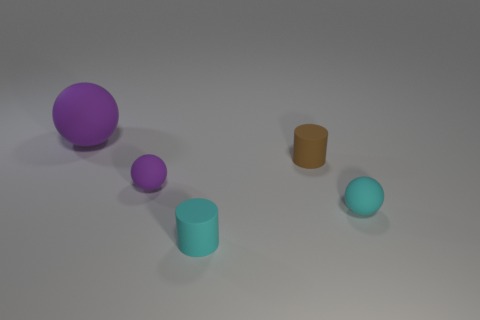Add 2 purple metal cylinders. How many objects exist? 7 Subtract all cylinders. How many objects are left? 3 Subtract 0 blue cylinders. How many objects are left? 5 Subtract all cylinders. Subtract all large brown rubber blocks. How many objects are left? 3 Add 3 small brown matte things. How many small brown matte things are left? 4 Add 3 cyan objects. How many cyan objects exist? 5 